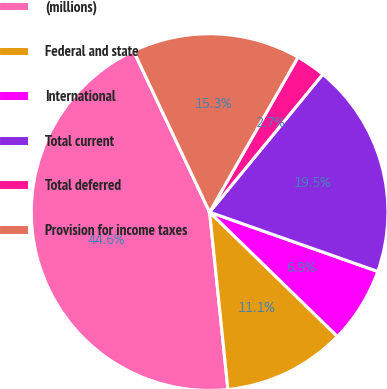<chart> <loc_0><loc_0><loc_500><loc_500><pie_chart><fcel>(millions)<fcel>Federal and state<fcel>International<fcel>Total current<fcel>Total deferred<fcel>Provision for income taxes<nl><fcel>44.62%<fcel>11.08%<fcel>6.88%<fcel>19.46%<fcel>2.69%<fcel>15.27%<nl></chart> 